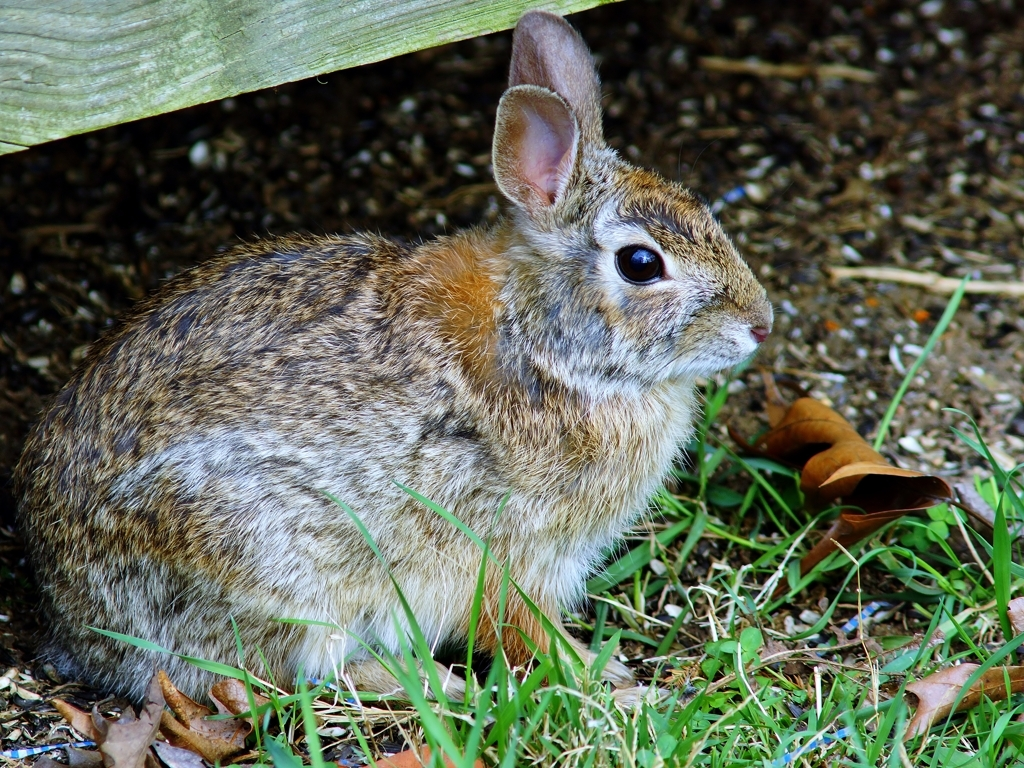Are the texture details of the animals clear and visible? Yes, the texture details of the rabbit in the image are quite vivid. The fur's individual strands are distinguishable, and the variation in color patterns, with shades of brown, black, and white, can be seen. The picture also shows how the rabbit's coat blends with the surrounding environment, which likely provides camouflage in its natural habitat. 